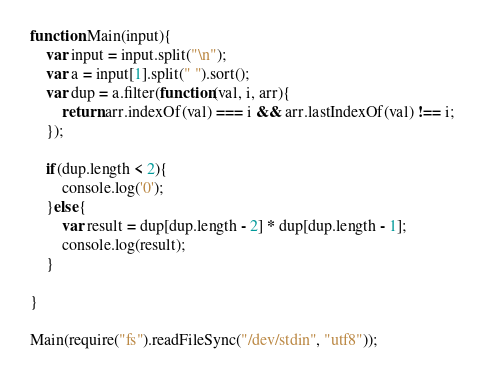<code> <loc_0><loc_0><loc_500><loc_500><_JavaScript_>function Main(input){
    var input = input.split("\n");
    var a = input[1].split(" ").sort();
    var dup = a.filter(function(val, i, arr){
        return arr.indexOf(val) === i && arr.lastIndexOf(val) !== i;
    });

    if(dup.length < 2){
        console.log('0');
    }else{
        var result = dup[dup.length - 2] * dup[dup.length - 1]; 
        console.log(result);
    }

}

Main(require("fs").readFileSync("/dev/stdin", "utf8"));
</code> 